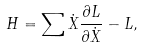Convert formula to latex. <formula><loc_0><loc_0><loc_500><loc_500>H = \sum \dot { X } \frac { \partial L } { \partial \dot { X } } - L ,</formula> 